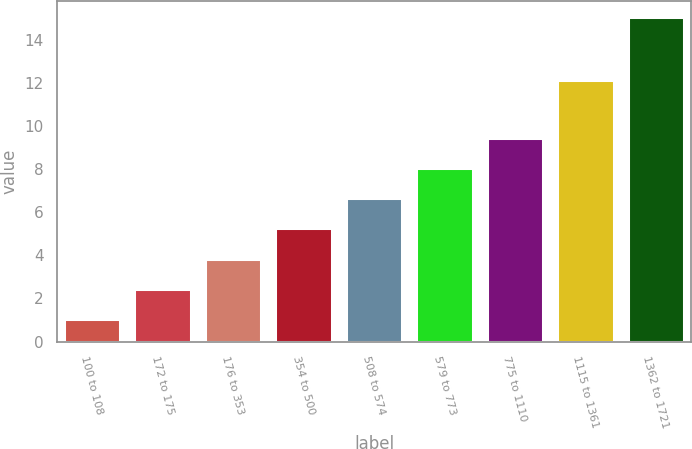<chart> <loc_0><loc_0><loc_500><loc_500><bar_chart><fcel>100 to 108<fcel>172 to 175<fcel>176 to 353<fcel>354 to 500<fcel>508 to 574<fcel>579 to 773<fcel>775 to 1110<fcel>1115 to 1361<fcel>1362 to 1721<nl><fcel>1.05<fcel>2.45<fcel>3.85<fcel>5.25<fcel>6.65<fcel>8.05<fcel>9.45<fcel>12.14<fcel>15.06<nl></chart> 